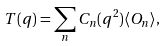<formula> <loc_0><loc_0><loc_500><loc_500>T ( q ) = \sum _ { n } C _ { n } ( q ^ { 2 } ) \langle O _ { n } \rangle , \\</formula> 